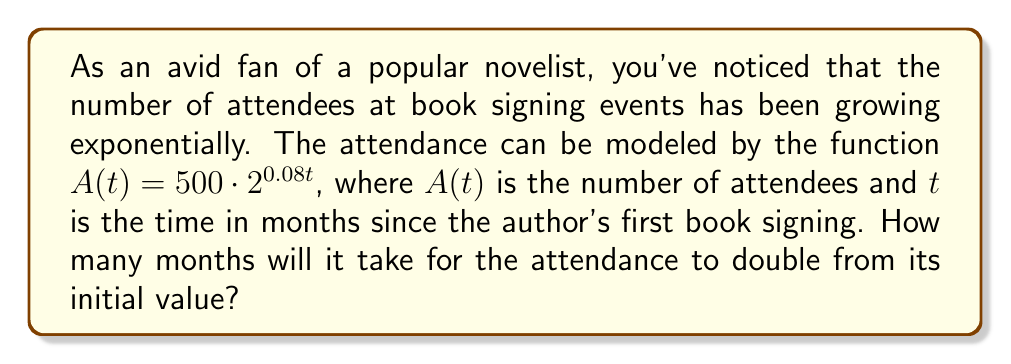Give your solution to this math problem. To solve this problem, we need to use the properties of exponential functions and logarithms. Let's approach this step-by-step:

1) The initial attendance (at $t=0$) is:
   $A(0) = 500 \cdot 2^{0.08 \cdot 0} = 500$

2) We want to find when the attendance becomes twice this value:
   $A(t) = 2 \cdot 500 = 1000$

3) Let's set up the equation:
   $500 \cdot 2^{0.08t} = 1000$

4) Divide both sides by 500:
   $2^{0.08t} = 2$

5) Now, we can take the logarithm (base 2) of both sides:
   $\log_2(2^{0.08t}) = \log_2(2)$

6) Using the logarithm property $\log_a(a^x) = x$, we get:
   $0.08t = 1$

7) Solve for $t$:
   $t = \frac{1}{0.08} = 12.5$

Therefore, it will take 12.5 months for the attendance to double.
Answer: 12.5 months 